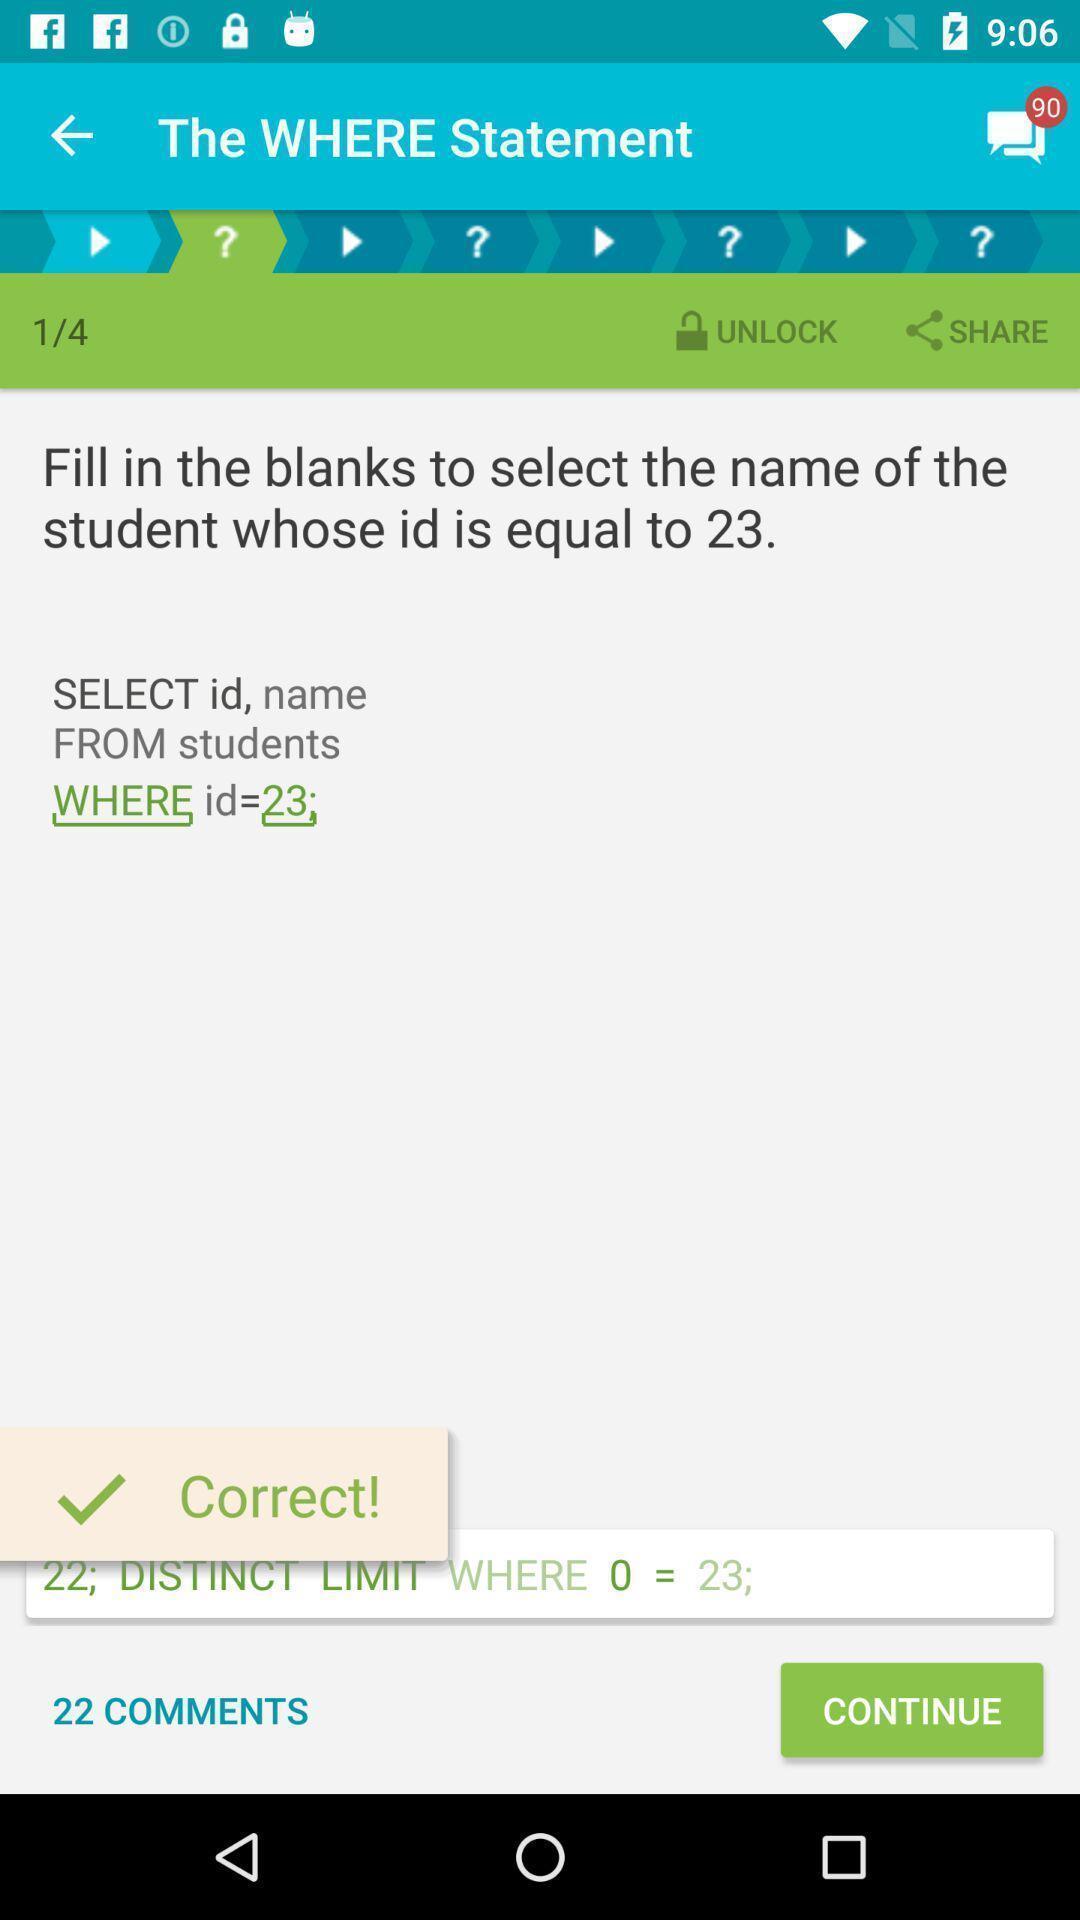What details can you identify in this image? Page displaying various options in a learning app. 